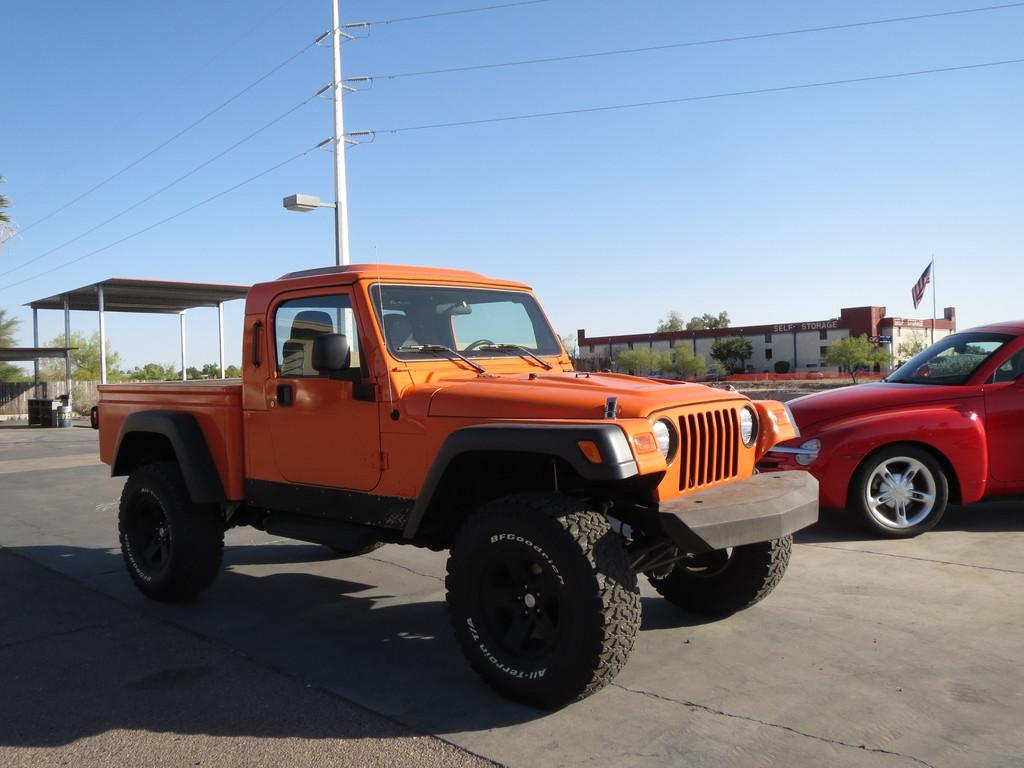What type of vehicles are in the image? There is a jeep and a car in the image. Where are the vehicles located? Both vehicles are on the road. What can be seen in the background of the image? There are buildings and electric poles in the background of the image. What is visible at the top of the image? The sky is visible in the image. What type of soup is being served in the image? There is no soup present in the image; it features a jeep and a car on the road. How does the wind affect the vehicles in the image? The image does not show any wind or its effects on the vehicles; they are stationary on the road. 